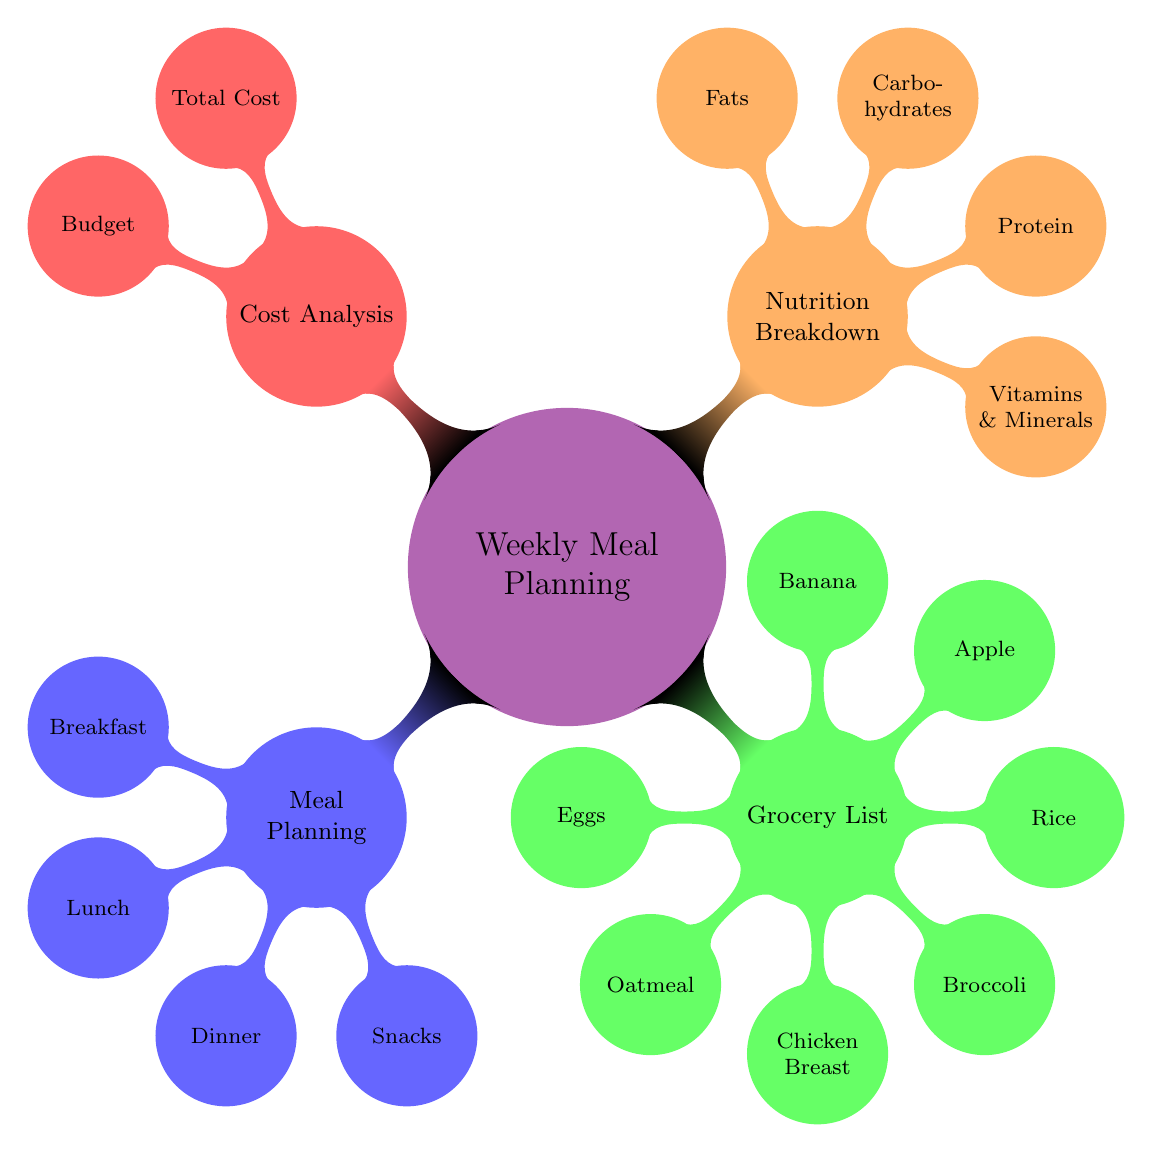What are the main categories of the Weekly Meal Planning? The main categories of the Weekly Meal Planning are shown as the first-level children in the mind map, which are Meal Planning, Grocery List, Nutrition Breakdown, and Cost Analysis. These categories are the first branches that stem from the central node.
Answer: Meal Planning, Grocery List, Nutrition Breakdown, Cost Analysis How many items are listed under the Grocery List? The Grocery List contains seven different food items as its child nodes. By counting the list presented in the diagram, we can see that there are Eggs, Oatmeal, Chicken Breast, Broccoli, Rice, Apple, and Banana.
Answer: Seven Which meal is included in the Meal Planning section? The Meal Planning section explicitly includes Breakfast, Lunch, Dinner, and Snacks as its child nodes. By identifying these child nodes, we can ascertain that all of them are categorized meals.
Answer: Breakfast, Lunch, Dinner, Snacks What is the focus of the Nutrition Breakdown? The Nutrition Breakdown focuses on four aspects which can be identified as child nodes: Vitamins & Minerals, Protein, Carbohydrates, and Fats. This reveals the key components of nutrition that are highlighted in this section of the diagram.
Answer: Vitamins & Minerals, Protein, Carbohydrates, Fats Which section includes Total Cost? The Total Cost is found in the Cost Analysis section, which is one of the four main categories stemming from the central theme of Weekly Meal Planning. It is represented as a child node under Cost Analysis.
Answer: Cost Analysis 